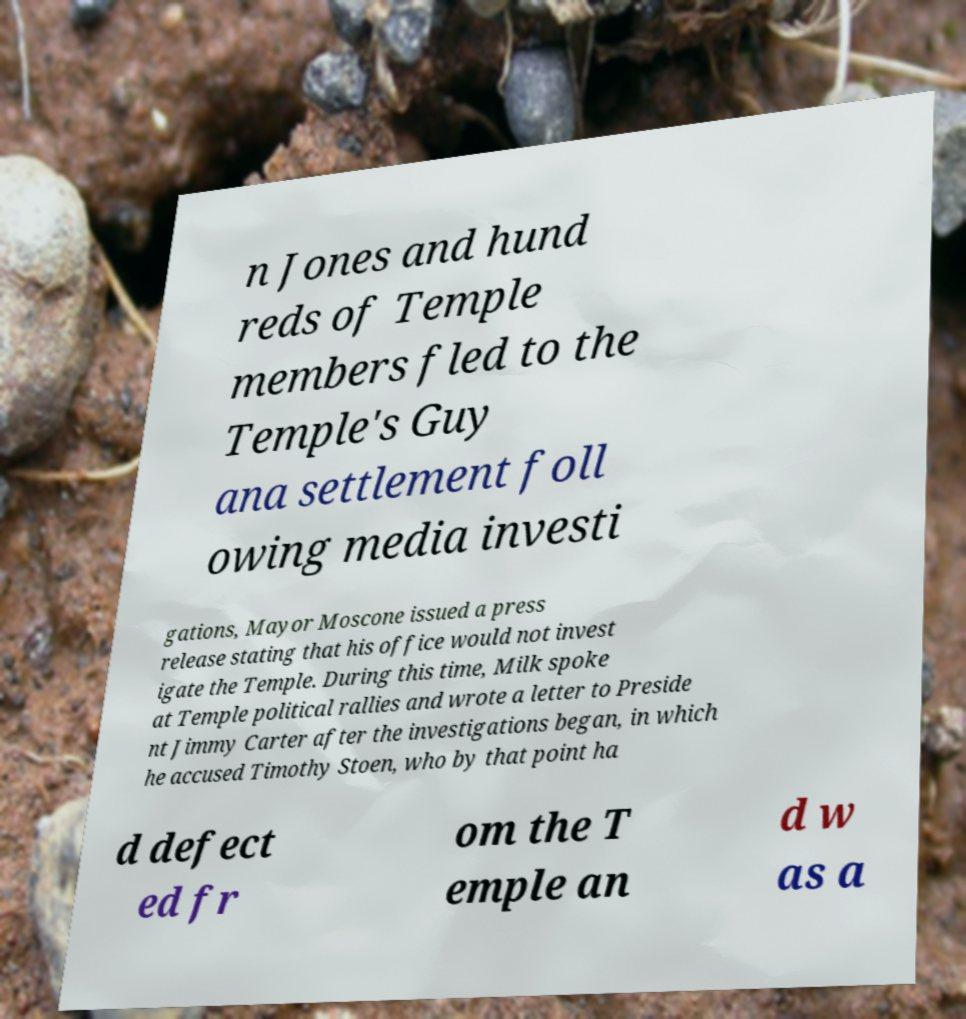There's text embedded in this image that I need extracted. Can you transcribe it verbatim? n Jones and hund reds of Temple members fled to the Temple's Guy ana settlement foll owing media investi gations, Mayor Moscone issued a press release stating that his office would not invest igate the Temple. During this time, Milk spoke at Temple political rallies and wrote a letter to Preside nt Jimmy Carter after the investigations began, in which he accused Timothy Stoen, who by that point ha d defect ed fr om the T emple an d w as a 